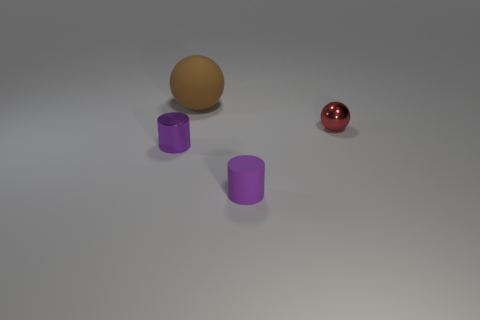Add 3 large objects. How many objects exist? 7 Subtract 0 cyan cubes. How many objects are left? 4 Subtract all tiny cylinders. Subtract all small green metal cylinders. How many objects are left? 2 Add 2 brown matte spheres. How many brown matte spheres are left? 3 Add 4 small purple objects. How many small purple objects exist? 6 